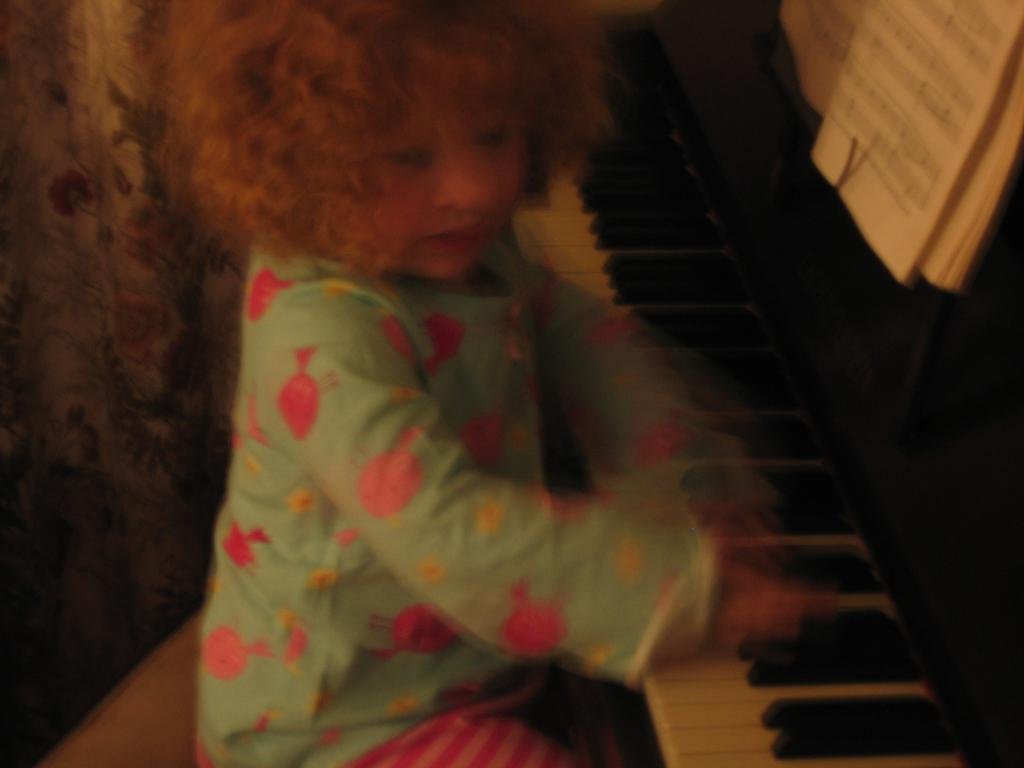Who is the main subject in the image? There is a small girl in the image. What is the girl doing in the image? The girl is sitting on a chair and playing the piano keys. What instrument is the girl playing in the image? There is a piano in the image, and the girl is playing its keys. What type of government is depicted in the image? There is no depiction of a government in the image; it features a small girl playing the piano. How many geese are present in the image? There are no geese present in the image; it features a small girl playing the piano. 